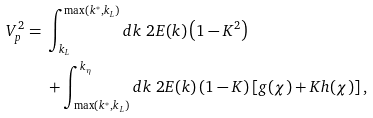Convert formula to latex. <formula><loc_0><loc_0><loc_500><loc_500>V _ { p } ^ { 2 } = & \ \int _ { k _ { L } } ^ { \max ( k ^ { * } , k _ { L } ) } d k \ 2 E ( k ) \left ( 1 - K ^ { 2 } \right ) \\ & \ + \int _ { \max ( k ^ { * } , k _ { L } ) } ^ { k _ { \eta } } d k \ 2 E ( k ) \left ( 1 - K \right ) \left [ g ( \chi ) + K h ( \chi ) \right ] ,</formula> 